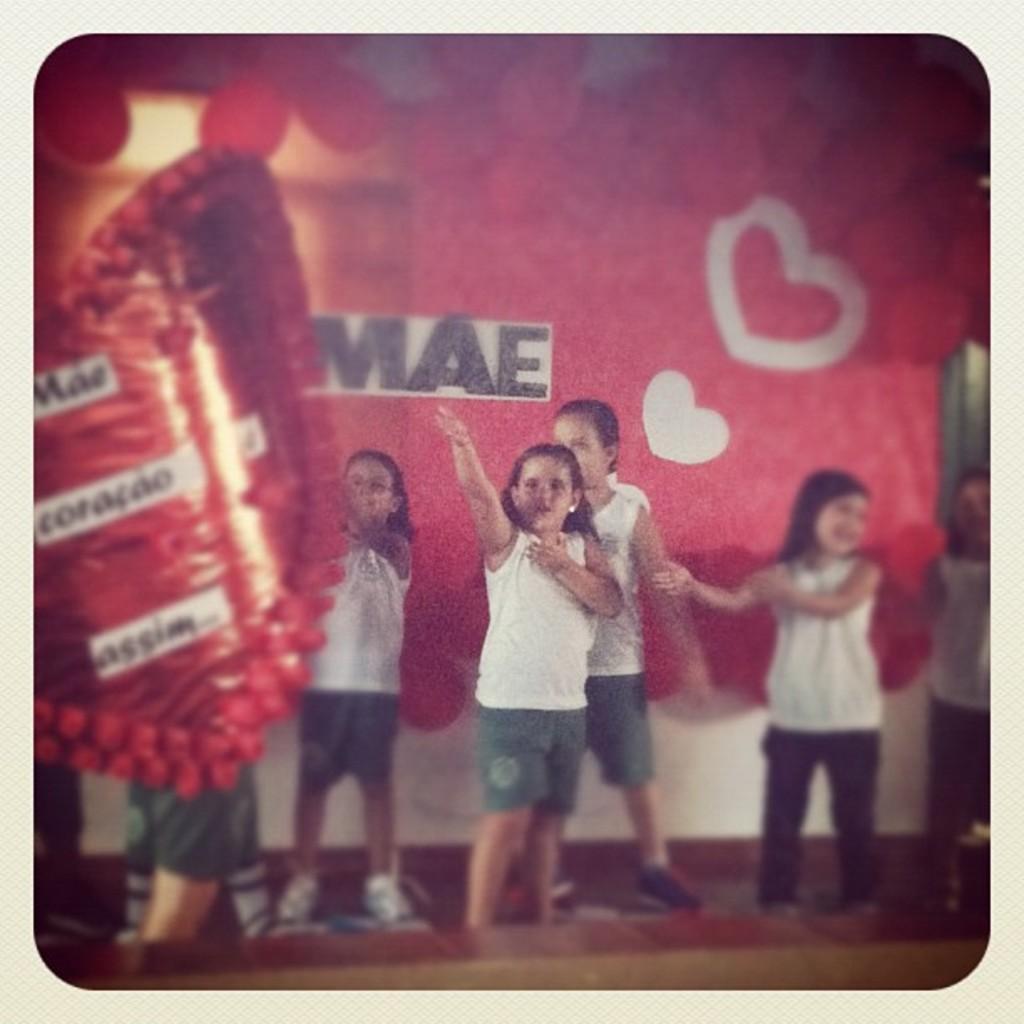How would you summarize this image in a sentence or two? There are group of children standing. I think they are dancing. This looks like a banner. I think these are the balloons, which are red in color. 